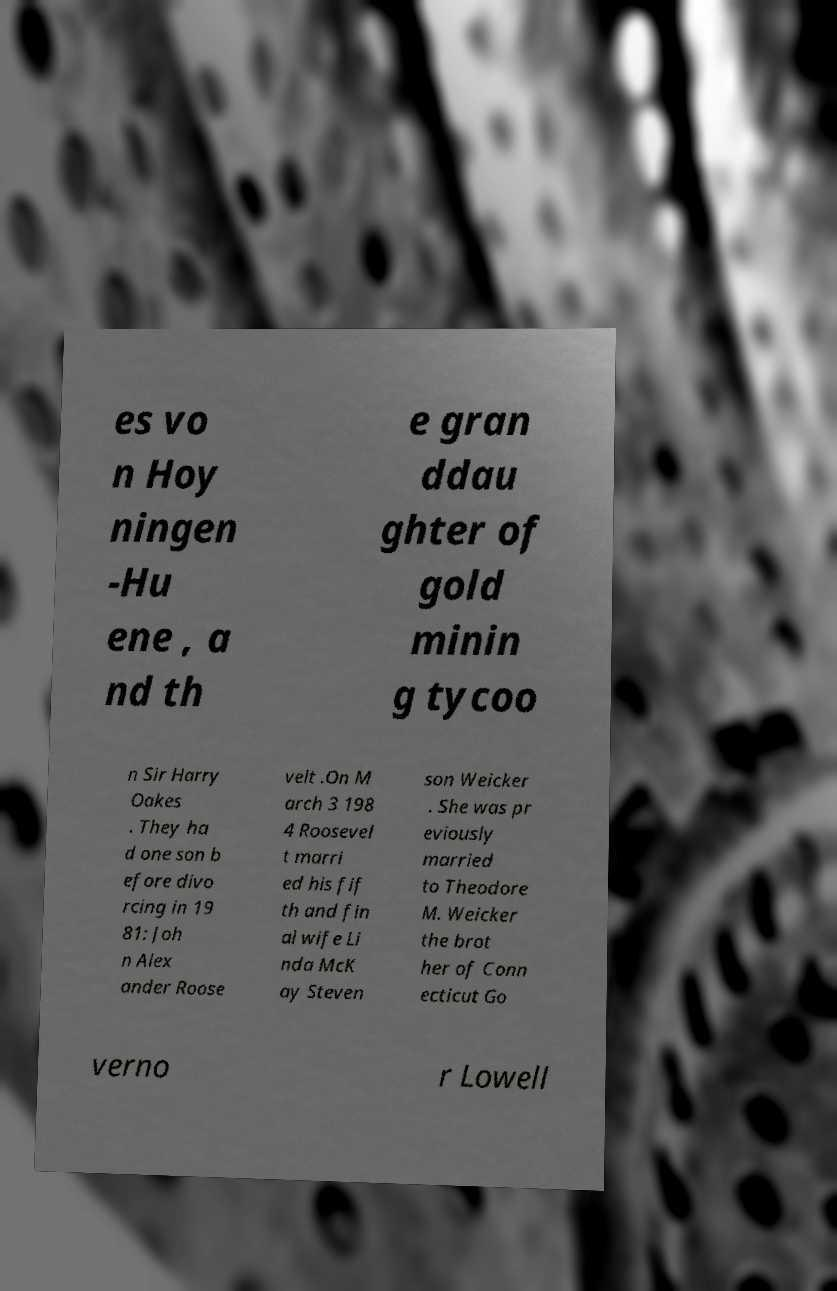Can you read and provide the text displayed in the image?This photo seems to have some interesting text. Can you extract and type it out for me? es vo n Hoy ningen -Hu ene , a nd th e gran ddau ghter of gold minin g tycoo n Sir Harry Oakes . They ha d one son b efore divo rcing in 19 81: Joh n Alex ander Roose velt .On M arch 3 198 4 Roosevel t marri ed his fif th and fin al wife Li nda McK ay Steven son Weicker . She was pr eviously married to Theodore M. Weicker the brot her of Conn ecticut Go verno r Lowell 